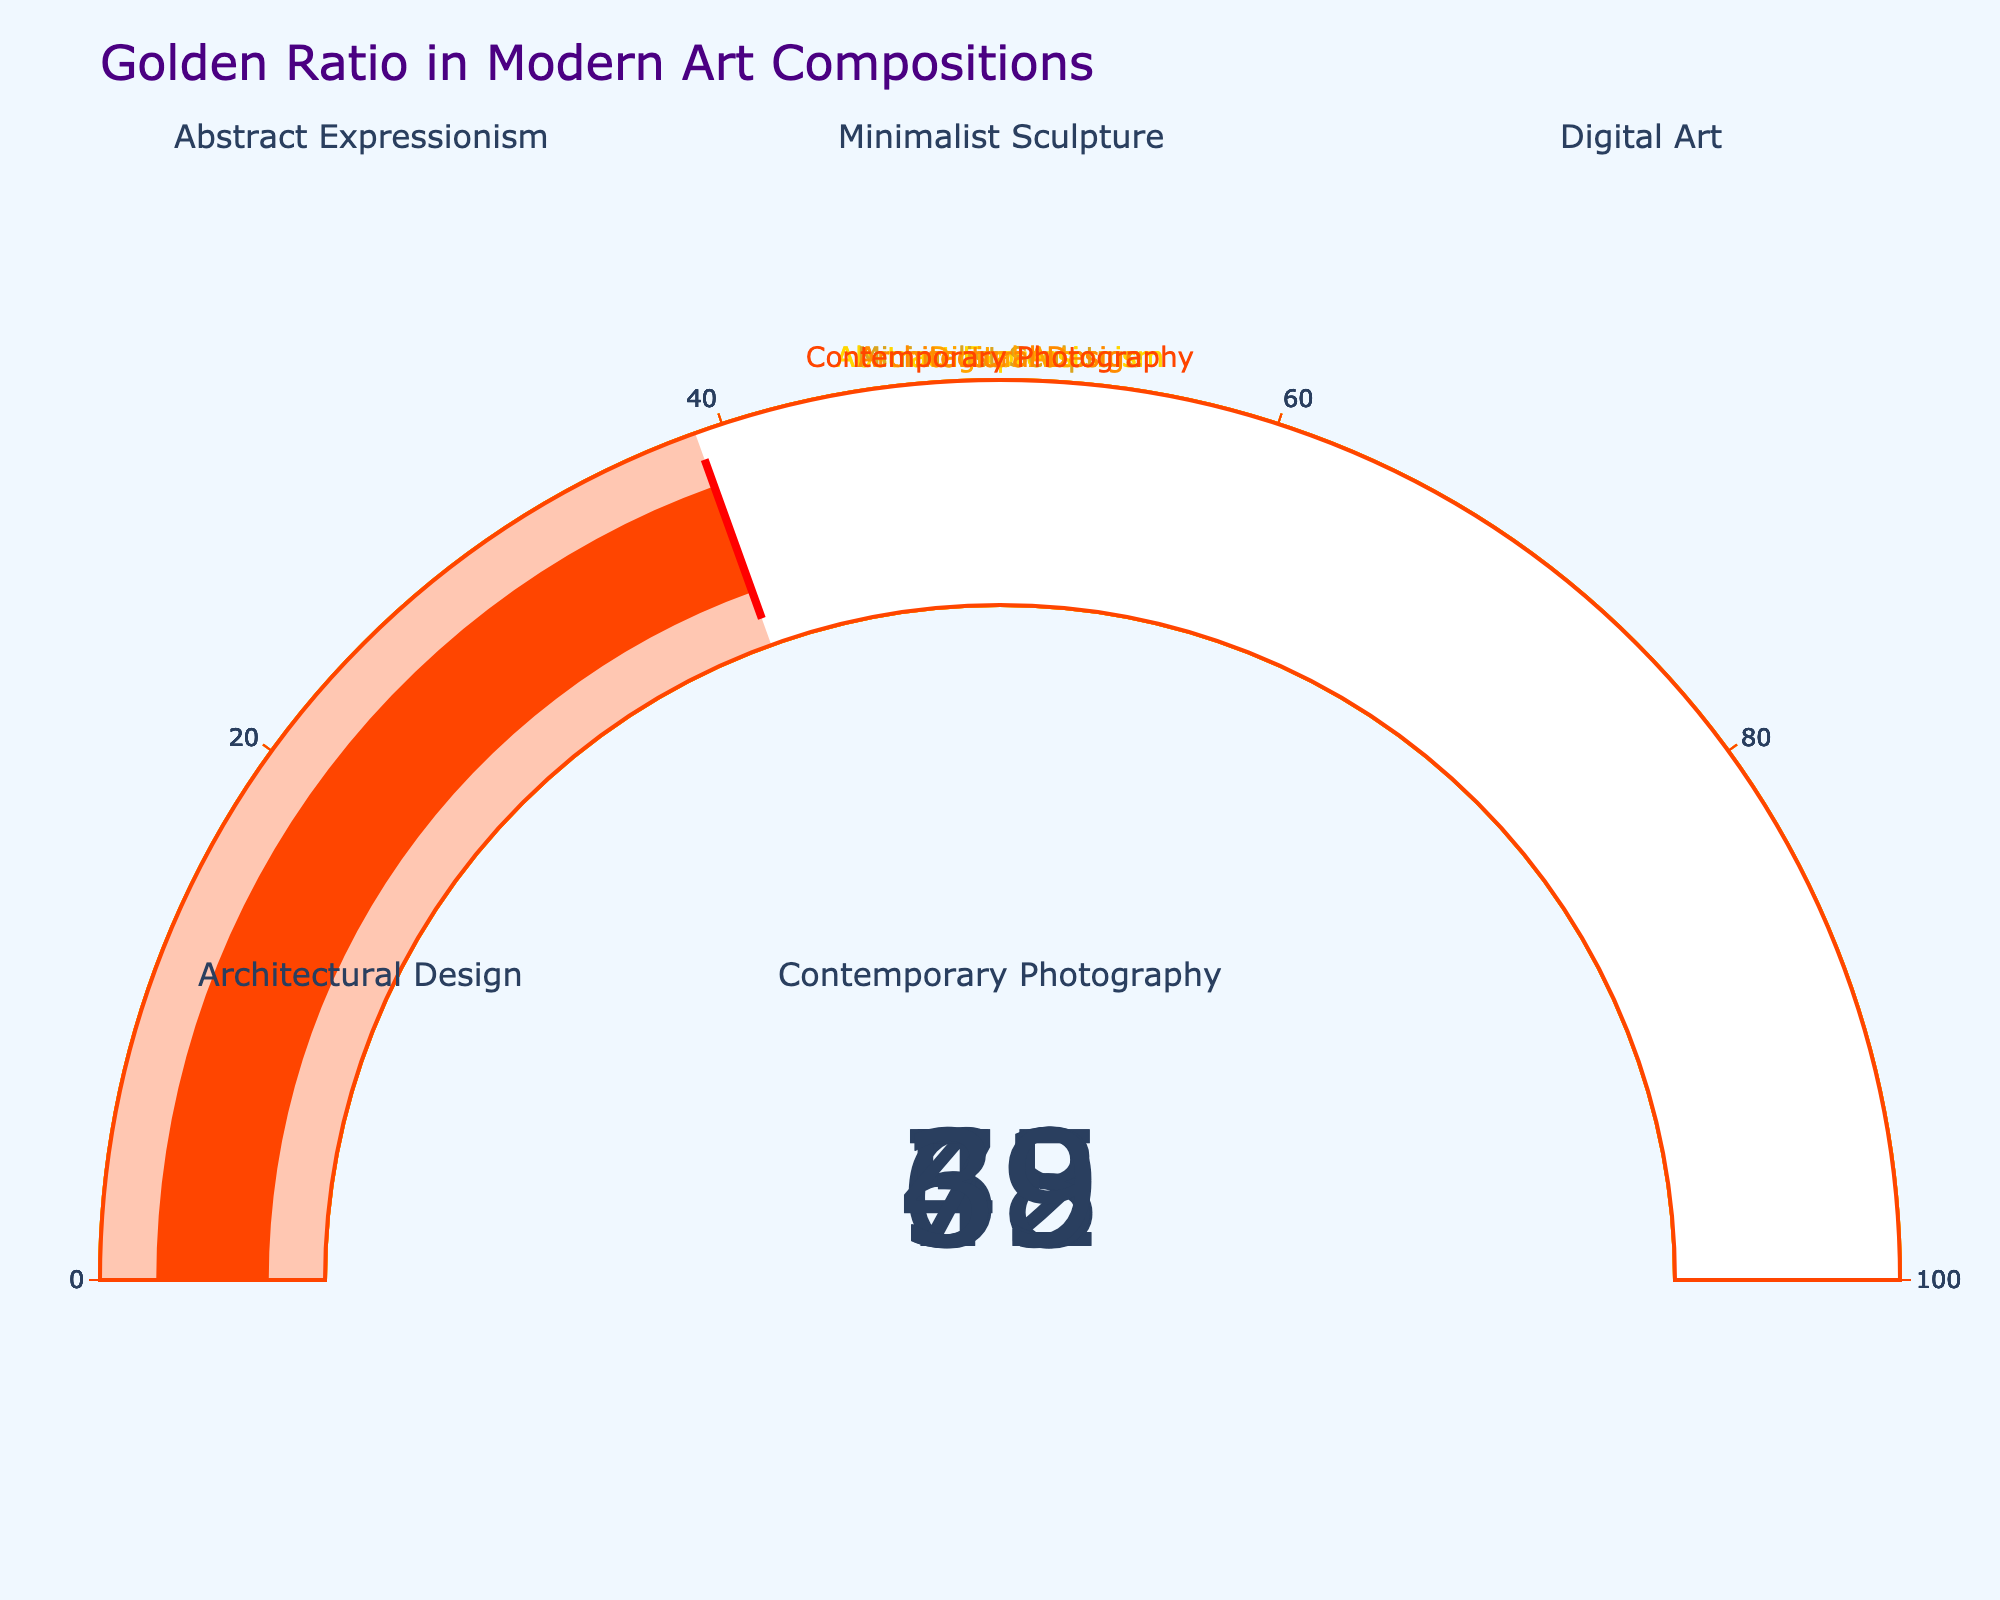Which category has the highest percentage of golden ratio applications? The gauge for "Architectural Design" shows the highest value at 73%, as the color fills up to 73% on the scale.
Answer: Architectural Design What is the average percentage of golden ratio applications across all categories? The average is calculated by summing the percentages and then dividing by the number of categories: (62 + 58 + 45 + 73 + 39) / 5 = 277 / 5 = 55.4.
Answer: 55.4 Which category has the lowest percentage of golden ratio applications? The gauge for "Contemporary Photography" shows the lowest value at 39%, as it has the smallest filled portion on its gauge.
Answer: Contemporary Photography How many categories have a percentage greater than 50%? The categories with percentages greater than 50% are "Abstract Expressionism" (62%), "Minimalist Sculpture" (58%), and "Architectural Design" (73%). This gives us a total of 3 categories.
Answer: 3 What is the difference in percentage between "Architectural Design" and "Digital Art"? The difference is calculated by subtracting the percentage of "Digital Art" from "Architectural Design": 73 - 45 = 28.
Answer: 28 Which category shows a percentage close to the midpoint (50%)? "Minimalist Sculpture" has a percentage of 58%, which is the closest to 50% compared to the other categories.
Answer: Minimalist Sculpture How does the percentage of "Abstract Expressionism" compare to "Contemporary Photography"? "Abstract Expressionism" is higher than "Contemporary Photography" by comparing their percentages: 62 is greater than 39.
Answer: Abstract Expressionism is higher If the threshold for a significant application of the golden ratio is 60%, which categories meet this criterion? The categories that meet this criterion are "Abstract Expressionism" (62%) and "Architectural Design" (73%) as they are both above 60%.
Answer: Abstract Expressionism, Architectural Design 